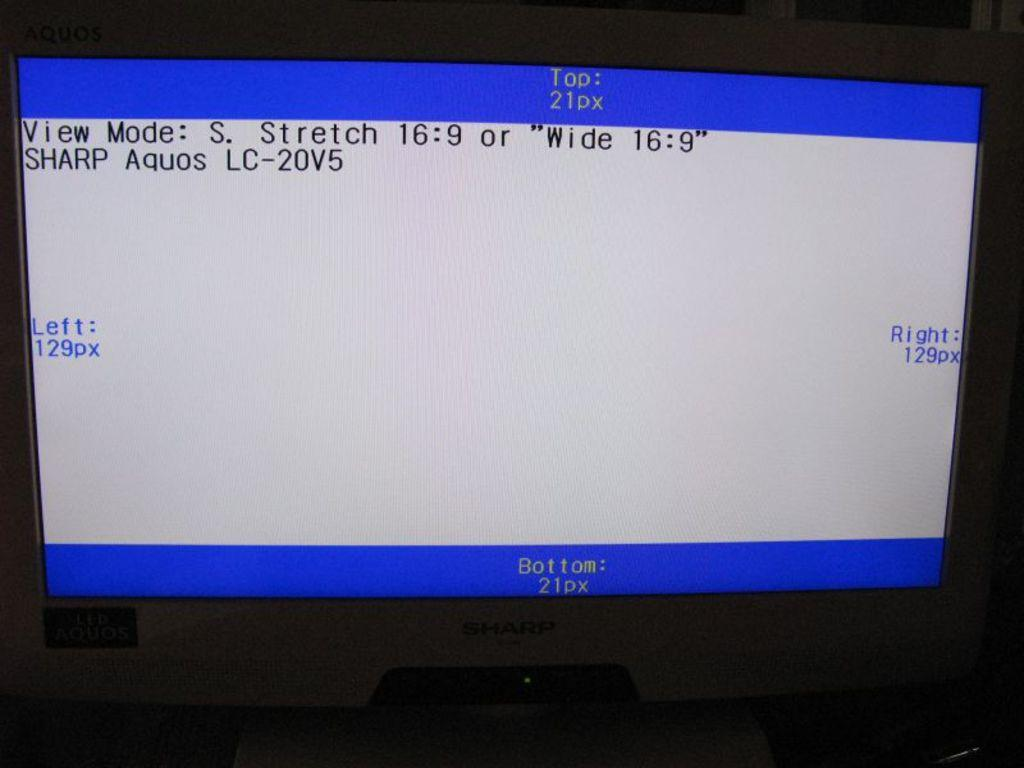<image>
Share a concise interpretation of the image provided. Picture placement is being adjusted and refined on a Sharp monitor. 